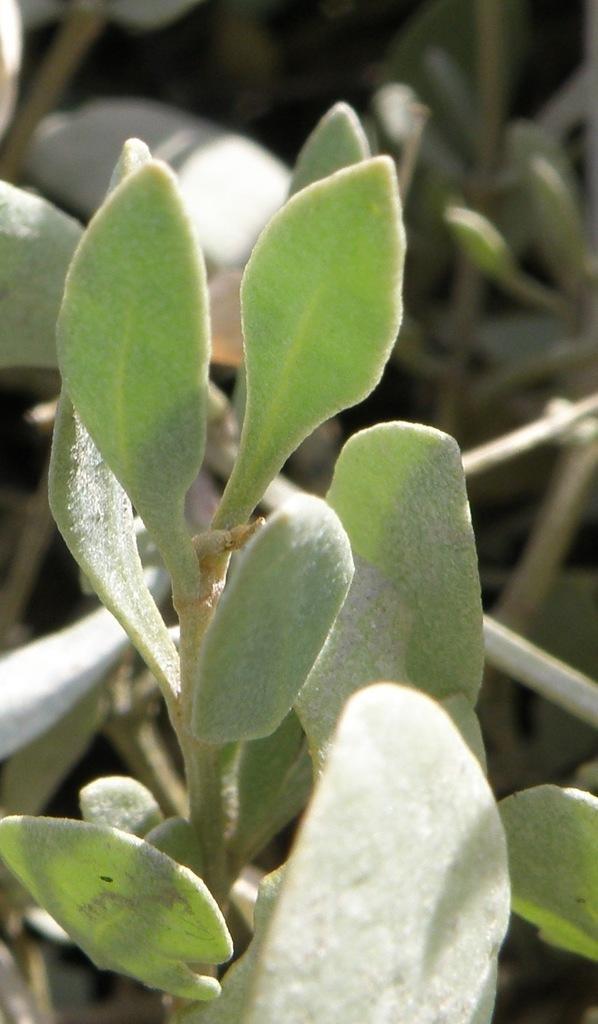In one or two sentences, can you explain what this image depicts? In the center of the image there are plants 